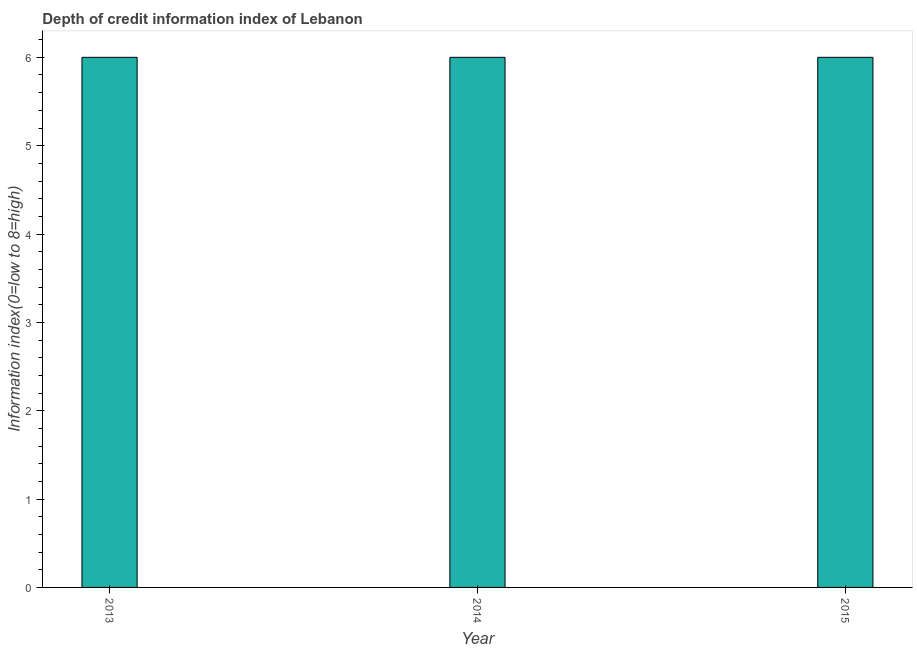Does the graph contain any zero values?
Your response must be concise. No. What is the title of the graph?
Provide a succinct answer. Depth of credit information index of Lebanon. What is the label or title of the X-axis?
Provide a short and direct response. Year. What is the label or title of the Y-axis?
Ensure brevity in your answer.  Information index(0=low to 8=high). What is the depth of credit information index in 2014?
Keep it short and to the point. 6. Across all years, what is the maximum depth of credit information index?
Your response must be concise. 6. In which year was the depth of credit information index maximum?
Make the answer very short. 2013. What is the sum of the depth of credit information index?
Keep it short and to the point. 18. What is the difference between the depth of credit information index in 2013 and 2014?
Offer a terse response. 0. What is the median depth of credit information index?
Offer a terse response. 6. In how many years, is the depth of credit information index greater than 5.4 ?
Offer a terse response. 3. Do a majority of the years between 2015 and 2013 (inclusive) have depth of credit information index greater than 0.2 ?
Your answer should be compact. Yes. What is the ratio of the depth of credit information index in 2014 to that in 2015?
Your answer should be very brief. 1. Is the depth of credit information index in 2014 less than that in 2015?
Offer a terse response. No. Is the difference between the depth of credit information index in 2013 and 2014 greater than the difference between any two years?
Ensure brevity in your answer.  Yes. Is the sum of the depth of credit information index in 2014 and 2015 greater than the maximum depth of credit information index across all years?
Offer a terse response. Yes. What is the difference between the highest and the lowest depth of credit information index?
Give a very brief answer. 0. In how many years, is the depth of credit information index greater than the average depth of credit information index taken over all years?
Provide a succinct answer. 0. How many bars are there?
Keep it short and to the point. 3. Are all the bars in the graph horizontal?
Your answer should be very brief. No. What is the difference between two consecutive major ticks on the Y-axis?
Your answer should be compact. 1. Are the values on the major ticks of Y-axis written in scientific E-notation?
Your answer should be compact. No. What is the Information index(0=low to 8=high) of 2013?
Provide a succinct answer. 6. What is the Information index(0=low to 8=high) of 2015?
Your response must be concise. 6. What is the ratio of the Information index(0=low to 8=high) in 2014 to that in 2015?
Make the answer very short. 1. 